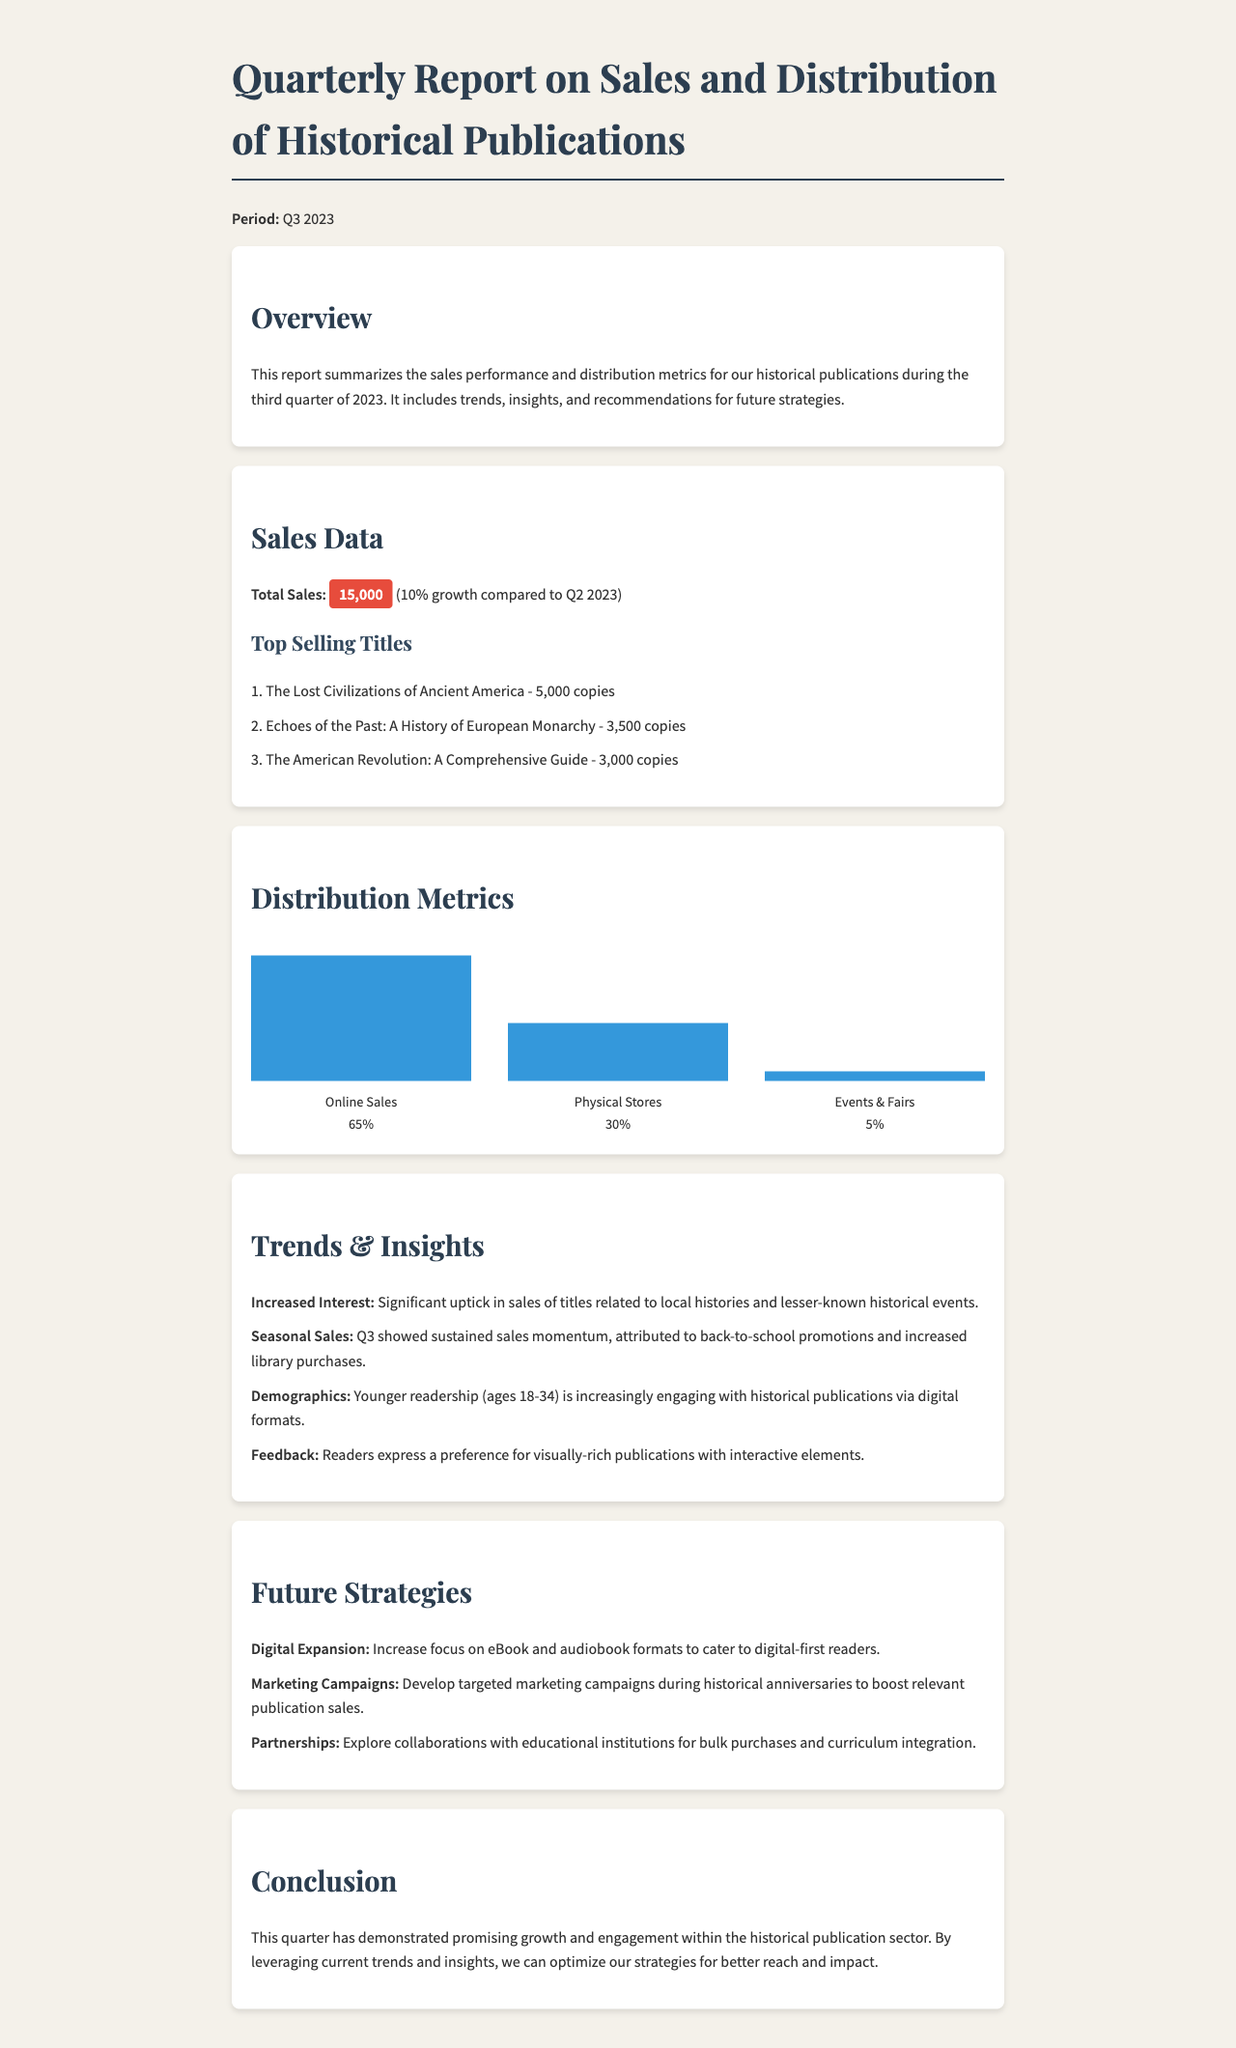What is the total sales for Q3 2023? The total sales is explicitly stated in the document as 15,000, which is the figure provided for that quarter.
Answer: 15,000 Which title sold the most copies? The document lists the top-selling titles, and the first title mentioned sold the most copies, which is 5,000.
Answer: The Lost Civilizations of Ancient America What percentage of sales came from online? The document indicates that online sales represent 65% of total sales, which is a specific percentage given in the distribution metrics.
Answer: 65% What demographic is increasingly engaging with publications? The document mentions that younger readership (ages 18-34) is increasingly engaging, indicating a specific demographic segment.
Answer: Ages 18-34 What was the percentage of sales from events and fairs? The document specifies that only 5% of sales came from events and fairs, which is a direct figure provided in the document.
Answer: 5% What strategy is suggested for reaching digital-first readers? The future strategies section advises an increase in focus on specific formats, which is aimed at digital-first readers.
Answer: Digital Expansion Which quarter's sales data is being reported? The document contains a clear reference to the period covered by the report as Q3 2023, which answers the time frame question.
Answer: Q3 2023 What is one reason for the sustained sales momentum in Q3? The document highlights that back-to-school promotions contributed to the sustained sales momentum, giving a specific factor for growth.
Answer: Back-to-school promotions What is a key recommendation for marketing strategies? The future strategies section advises developing targeted marketing campaigns during relevant historical anniversaries, which is a specific recommendation provided.
Answer: Targeted marketing campaigns 